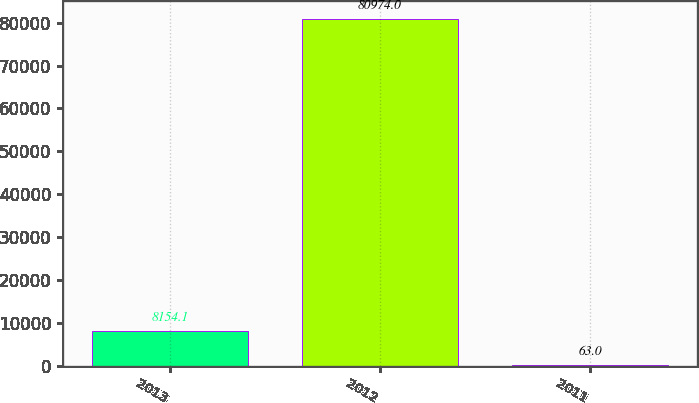<chart> <loc_0><loc_0><loc_500><loc_500><bar_chart><fcel>2013<fcel>2012<fcel>2011<nl><fcel>8154.1<fcel>80974<fcel>63<nl></chart> 